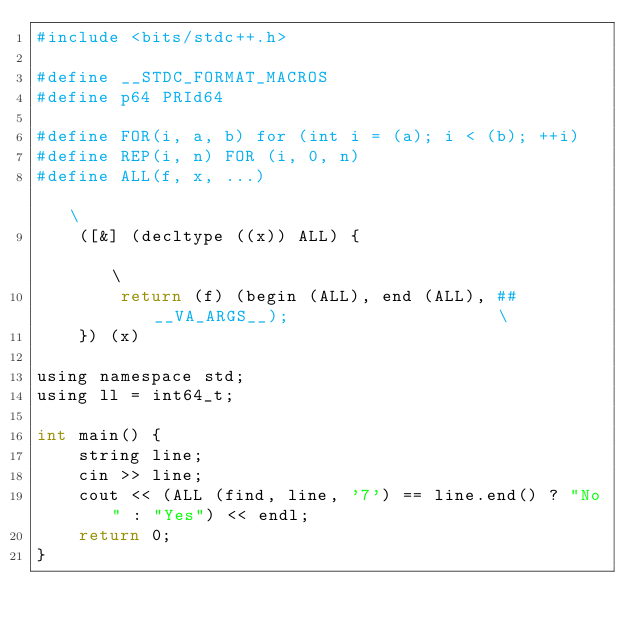<code> <loc_0><loc_0><loc_500><loc_500><_Python_>#include <bits/stdc++.h>

#define __STDC_FORMAT_MACROS
#define p64 PRId64

#define FOR(i, a, b) for (int i = (a); i < (b); ++i)
#define REP(i, n) FOR (i, 0, n)
#define ALL(f, x, ...)                                                         \
    ([&] (decltype ((x)) ALL) {                                                \
        return (f) (begin (ALL), end (ALL), ##__VA_ARGS__);                    \
    }) (x)

using namespace std;
using ll = int64_t;

int main() {
    string line;
    cin >> line;
    cout << (ALL (find, line, '7') == line.end() ? "No" : "Yes") << endl;
    return 0;
}
</code> 